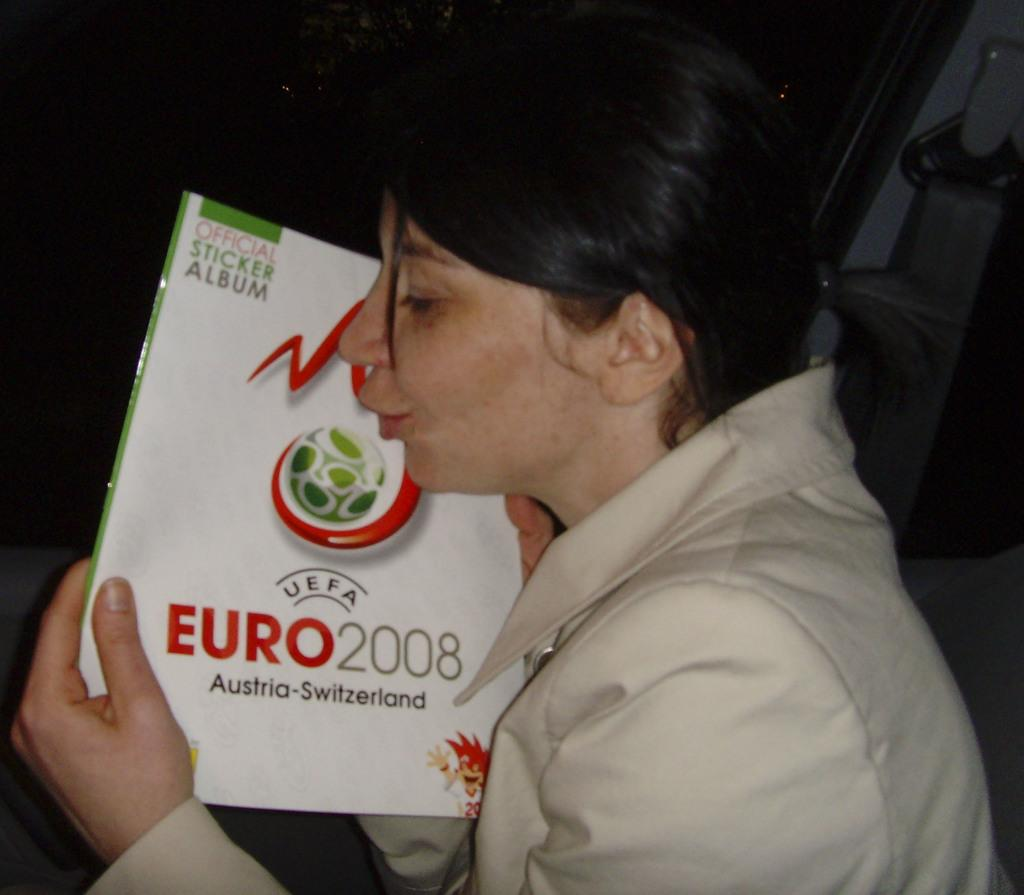Who is the main subject in the image? There is a woman in the image. What is the woman wearing? The woman is wearing a blazer. What is the woman holding in the image? The woman is holding a book. Can you describe the background of the image? The background of the image is dark. What type of health issues does the woman in the image have? There is no information about the woman's health in the image, so it cannot be determined from the picture. 